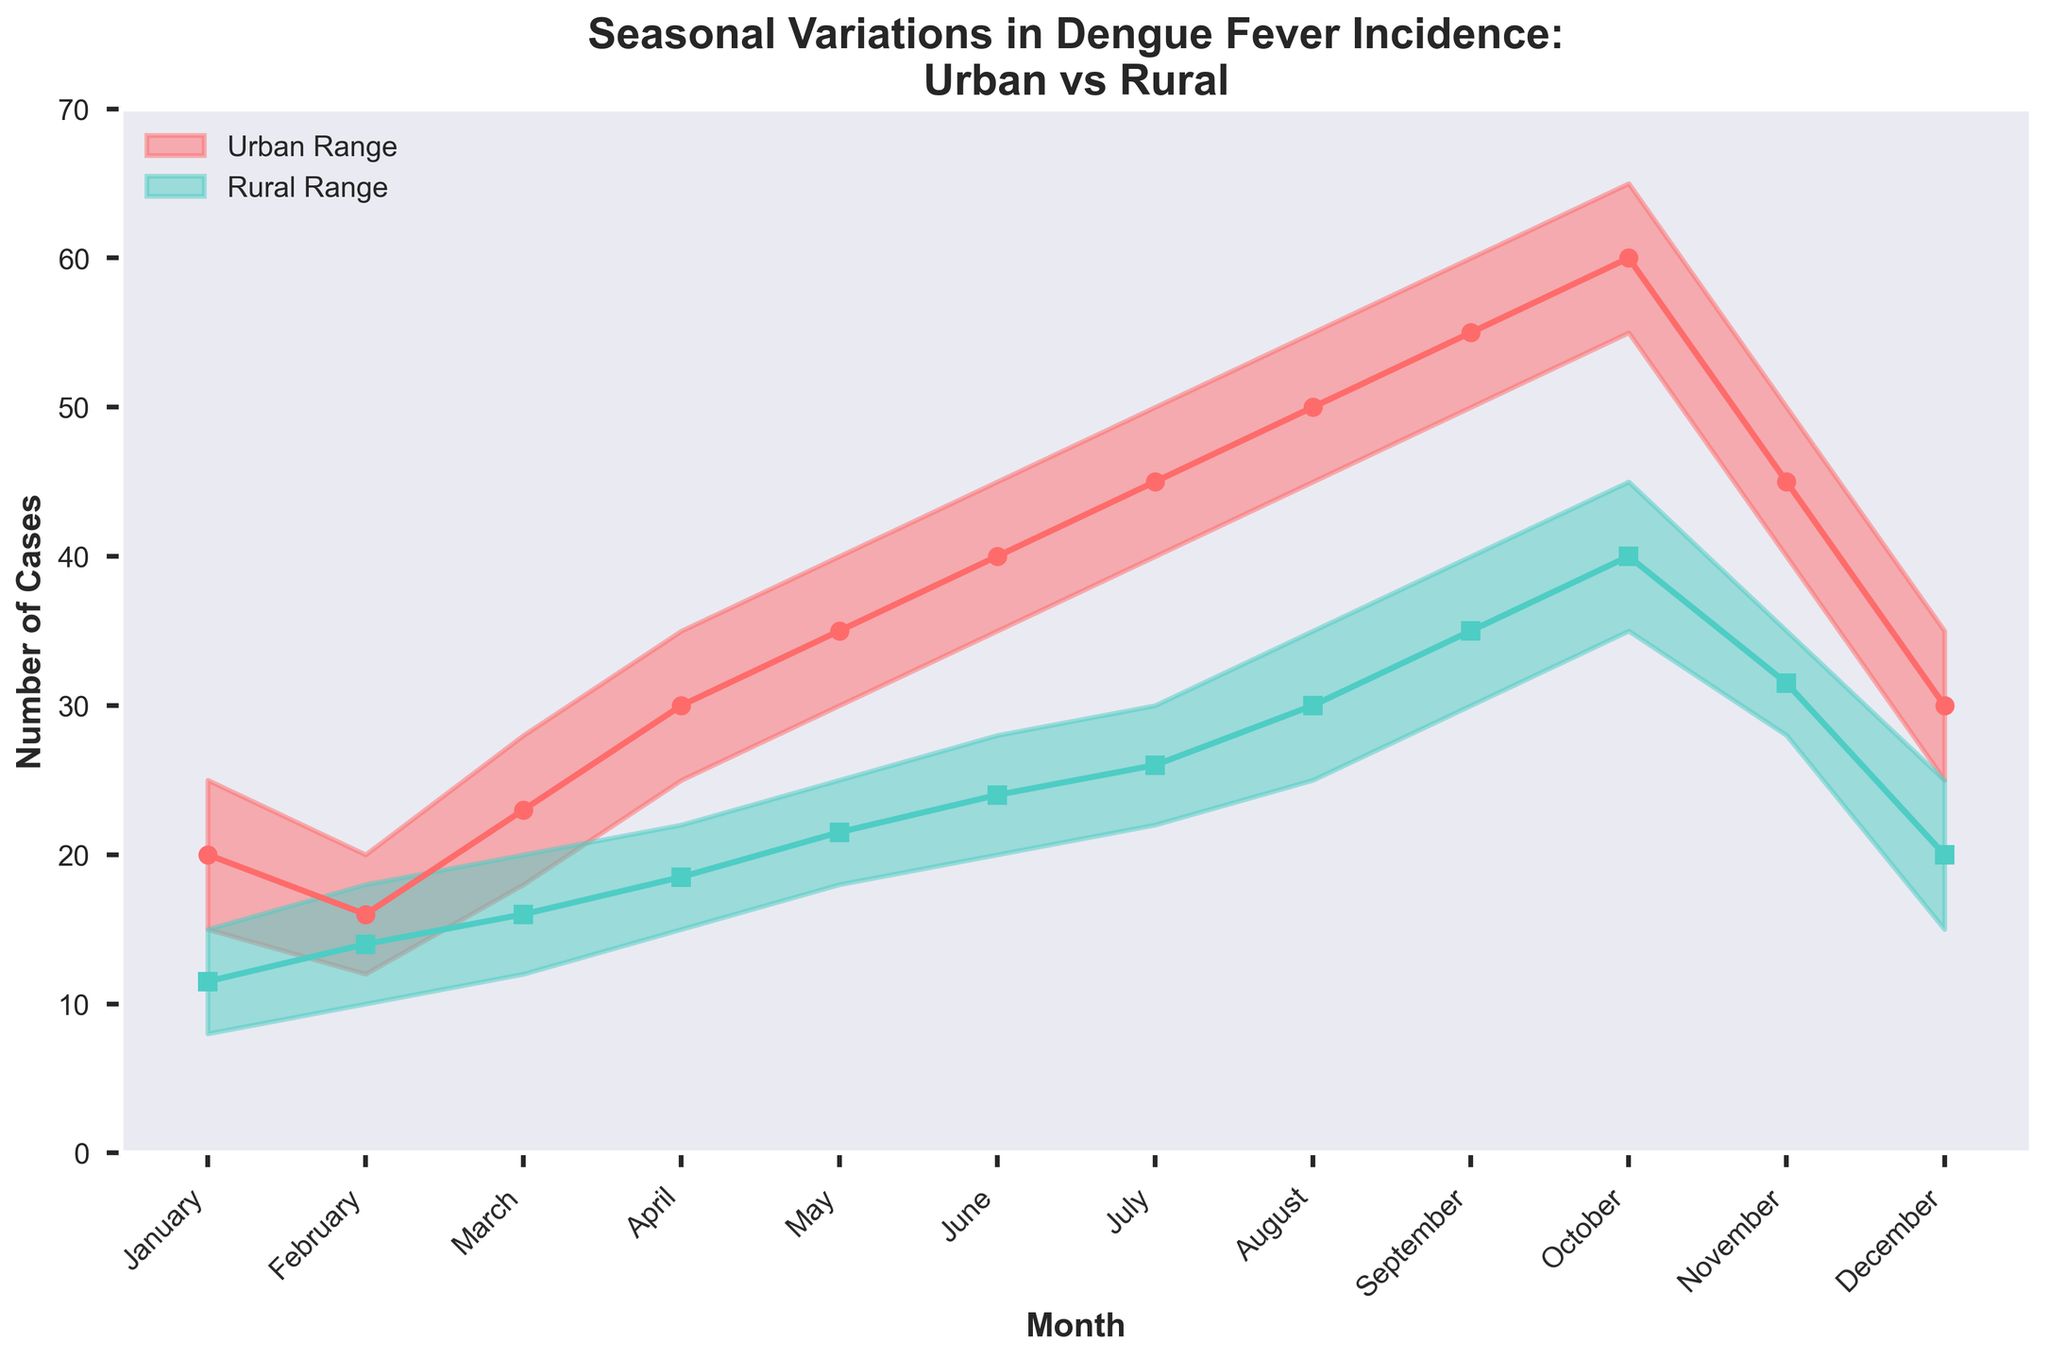What is the title of the figure? The title of the figure is at the top of the plot, usually in bold text. It provides an overview of the content of the plot. In this case, the title reads "Seasonal Variations in Dengue Fever Incidence: Urban vs Rural".
Answer: Seasonal Variations in Dengue Fever Incidence: Urban vs Rural What months show the highest range of Dengue fever cases in urban areas? To identify the month with the highest range of cases in urban areas, we need to look for the widest gap between the minimum and maximum cases. The months with the highest range should be visually inspected, and August and September show the widest gap between the minimum and maximum cases (45 to 55 and 50 to 60 respectively).
Answer: August and September What's the average number of Dengue cases in rural areas in July? To find the average number of Dengue cases in rural areas for July, we need to add the minimum and maximum cases for rural areas in July and divide by 2. The minimum is 22 and the maximum is 30. (22 + 30) / 2 = 26 cases.
Answer: 26 In which month do rural areas have the minimum number of cases and what are the values? The month with the minimum number of cases in rural areas can be seen by identifying the smallest value on the rural range area graph. January has the minimum values, with a range from 8 to 15 cases.
Answer: January, 8 to 15 cases How does the Dengue incidence in urban areas in April compare to that in rural areas? To compare Dengue incidence in April, we need to check the number of cases in urban and rural areas. In April, urban areas have a minimum of 25 and a maximum of 35 cases, while rural areas have a minimum of 15 and a maximum of 22 cases. Urban regions have higher cases compared to rural.
Answer: Higher in urban areas Which month shows the lowest variation of Dengue cases in urban areas and what is that variation? The variation is the difference between the maximum and minimum values. February has the lowest variation for urban areas, calculated as maximum (20) minus minimum (12), giving a variation of 8 cases.
Answer: February, 8 cases From May to October, in which month do rural areas show the highest number of cases? To find the month with the highest number of cases in rural areas from May to October, we need to examine the maximum case values in these months. October has the highest maximum value of 45 cases in rural areas.
Answer: October What is the pattern of Dengue cases in urban areas over the months? The pattern in urban areas is observed by following the trend of cases over the months. Starting from January to October, there is a rise in the number of cases, reaching a peak in October, followed by a decline in November and December.
Answer: Gradual rise till October, then decline What are the lowest and highest number of Dengue cases in December for both urban and rural areas? For December, urban areas have a range of 25 to 35 cases, while rural areas have a range of 15 to 25 cases. The lowest number in December is 15 (rural) and the highest is 35 (urban).
Answer: Lowest: 15 (rural), Highest: 35 (urban) Which area shows more variation in case numbers, urban or rural, over the entire year? By quantifying the range for each month and averaging, or simply observing visually the wider spread of the shaded area, urban areas show more variation compared to rural. Urban ranges are consistently wider.
Answer: Urban areas 